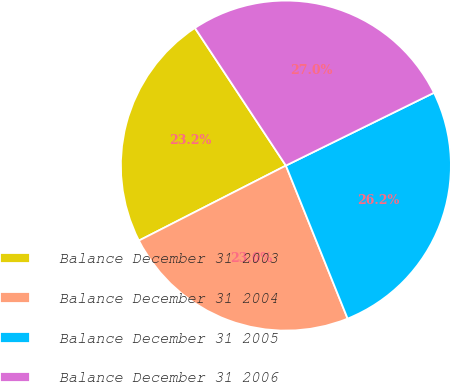Convert chart. <chart><loc_0><loc_0><loc_500><loc_500><pie_chart><fcel>Balance December 31 2003<fcel>Balance December 31 2004<fcel>Balance December 31 2005<fcel>Balance December 31 2006<nl><fcel>23.21%<fcel>23.59%<fcel>26.17%<fcel>27.02%<nl></chart> 